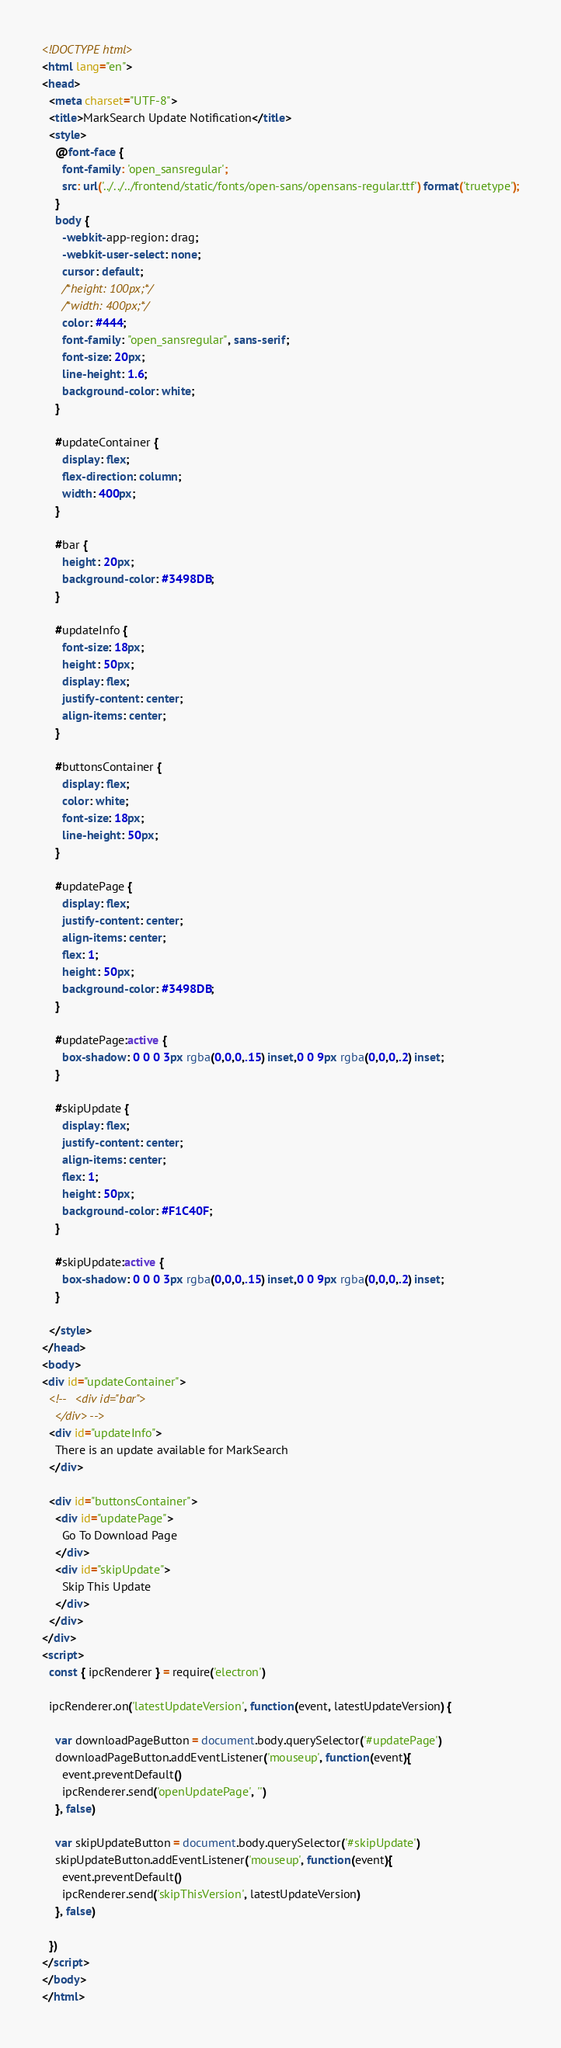<code> <loc_0><loc_0><loc_500><loc_500><_HTML_><!DOCTYPE html>
<html lang="en">
<head>
  <meta charset="UTF-8">
  <title>MarkSearch Update Notification</title>
  <style>
    @font-face {
      font-family: 'open_sansregular';
      src: url('../../../frontend/static/fonts/open-sans/opensans-regular.ttf') format('truetype');
    }
    body {
      -webkit-app-region: drag;
      -webkit-user-select: none;
      cursor: default;
      /*height: 100px;*/
      /*width: 400px;*/
      color: #444;
      font-family: "open_sansregular", sans-serif;
      font-size: 20px;
      line-height: 1.6;
      background-color: white;
    }

    #updateContainer {
      display: flex;
      flex-direction: column;
      width: 400px;
    }

    #bar {
      height: 20px;
      background-color: #3498DB;
    }

    #updateInfo {
      font-size: 18px;
      height: 50px;
      display: flex;
      justify-content: center;
      align-items: center;
    }

    #buttonsContainer {
      display: flex;
      color: white;
      font-size: 18px;
      line-height: 50px;
    }

    #updatePage {
      display: flex;
      justify-content: center;
      align-items: center;
      flex: 1;
      height: 50px;
      background-color: #3498DB;
    }

    #updatePage:active {
      box-shadow: 0 0 0 3px rgba(0,0,0,.15) inset,0 0 9px rgba(0,0,0,.2) inset;
    }

    #skipUpdate {
      display: flex;
      justify-content: center;
      align-items: center;
      flex: 1;
      height: 50px;
      background-color: #F1C40F;
    }

    #skipUpdate:active {
      box-shadow: 0 0 0 3px rgba(0,0,0,.15) inset,0 0 9px rgba(0,0,0,.2) inset;
    }

  </style>
</head>
<body>
<div id="updateContainer">
  <!--   <div id="bar">
    </div> -->
  <div id="updateInfo">
    There is an update available for MarkSearch
  </div>

  <div id="buttonsContainer">
    <div id="updatePage">
      Go To Download Page
    </div>
    <div id="skipUpdate">
      Skip This Update
    </div>
  </div>
</div>
<script>
  const { ipcRenderer } = require('electron')

  ipcRenderer.on('latestUpdateVersion', function(event, latestUpdateVersion) {

    var downloadPageButton = document.body.querySelector('#updatePage')
    downloadPageButton.addEventListener('mouseup', function(event){
      event.preventDefault()
      ipcRenderer.send('openUpdatePage', '')
    }, false)

    var skipUpdateButton = document.body.querySelector('#skipUpdate')
    skipUpdateButton.addEventListener('mouseup', function(event){
      event.preventDefault()
      ipcRenderer.send('skipThisVersion', latestUpdateVersion)
    }, false)

  })
</script>
</body>
</html></code> 